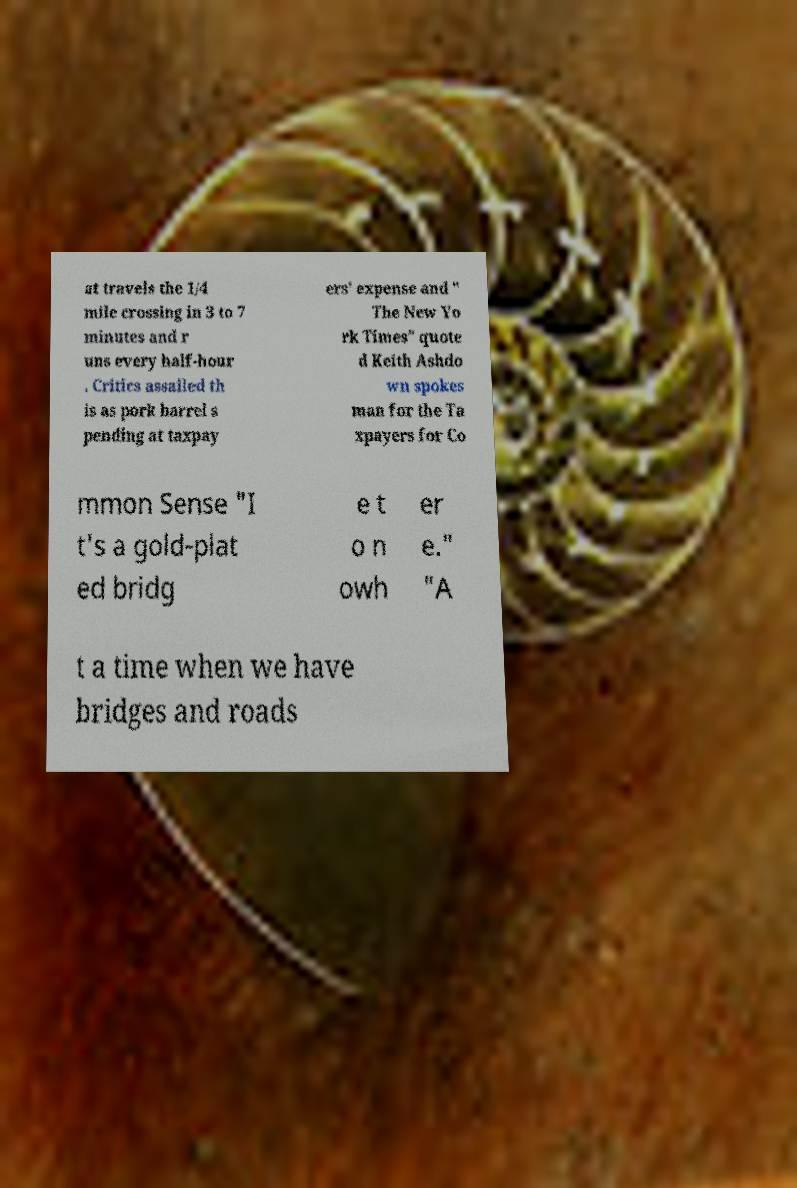Can you accurately transcribe the text from the provided image for me? at travels the 1/4 mile crossing in 3 to 7 minutes and r uns every half-hour . Critics assailed th is as pork barrel s pending at taxpay ers' expense and " The New Yo rk Times" quote d Keith Ashdo wn spokes man for the Ta xpayers for Co mmon Sense "I t's a gold-plat ed bridg e t o n owh er e." "A t a time when we have bridges and roads 